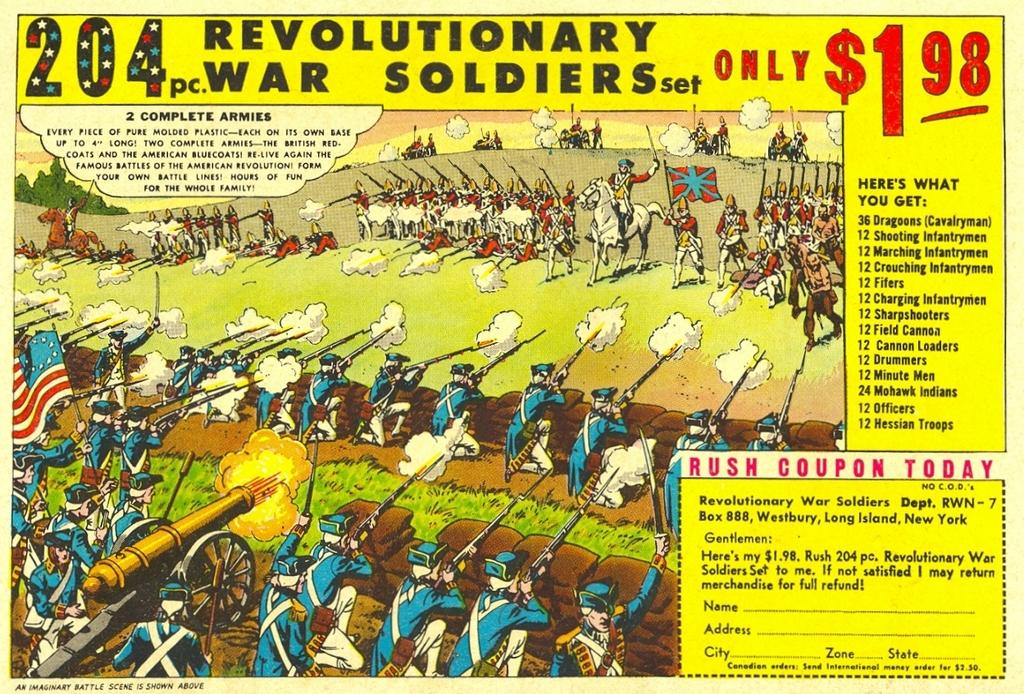<image>
Summarize the visual content of the image. A picture of soldiers firing guns advertising Revolutionary War Soldiers set for only $1.98 